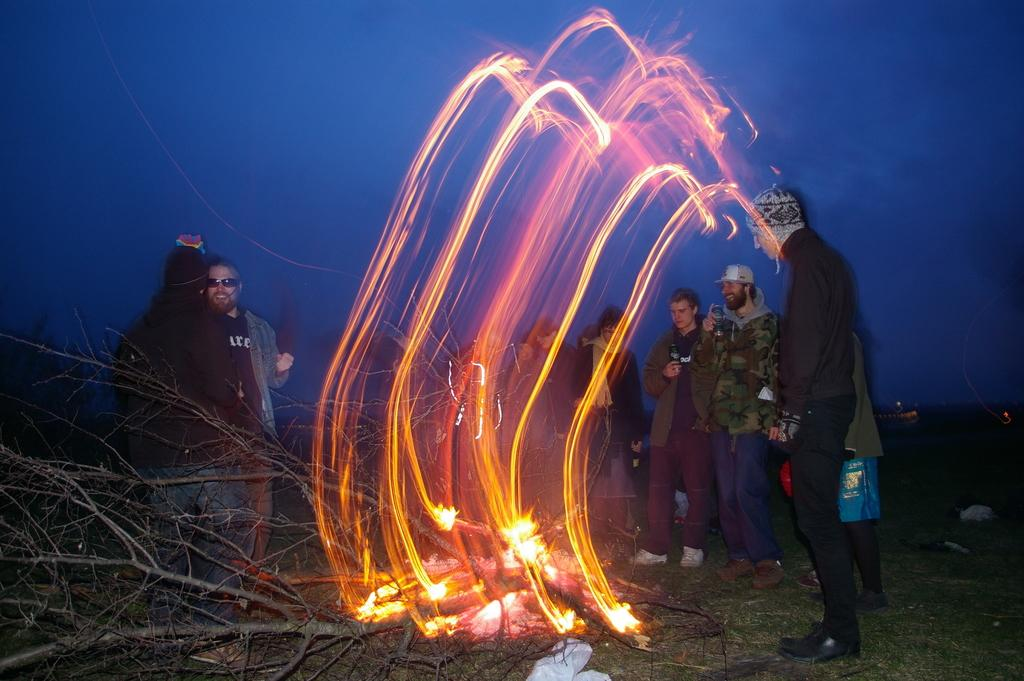How many people are visible in the image? There are many people standing in the image. Where was the image taken? The image appears to be taken outside. What is the main focus of the image? There is a fire in the middle of the image. What type of vegetation is present near the fire? Dry plants are present to the left of the fire. What can be seen in the sky in the image? The sky is visible at the top of the image. What type of birds can be seen flying in the lunchroom in the image? There are no birds or lunchrooms present in the image; it features a fire with dry plants and many people standing outside. How old is the baby in the image? There is no baby present in the image. 